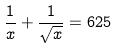Convert formula to latex. <formula><loc_0><loc_0><loc_500><loc_500>\frac { 1 } { x } + \frac { 1 } { \sqrt { x } } = 6 2 5</formula> 